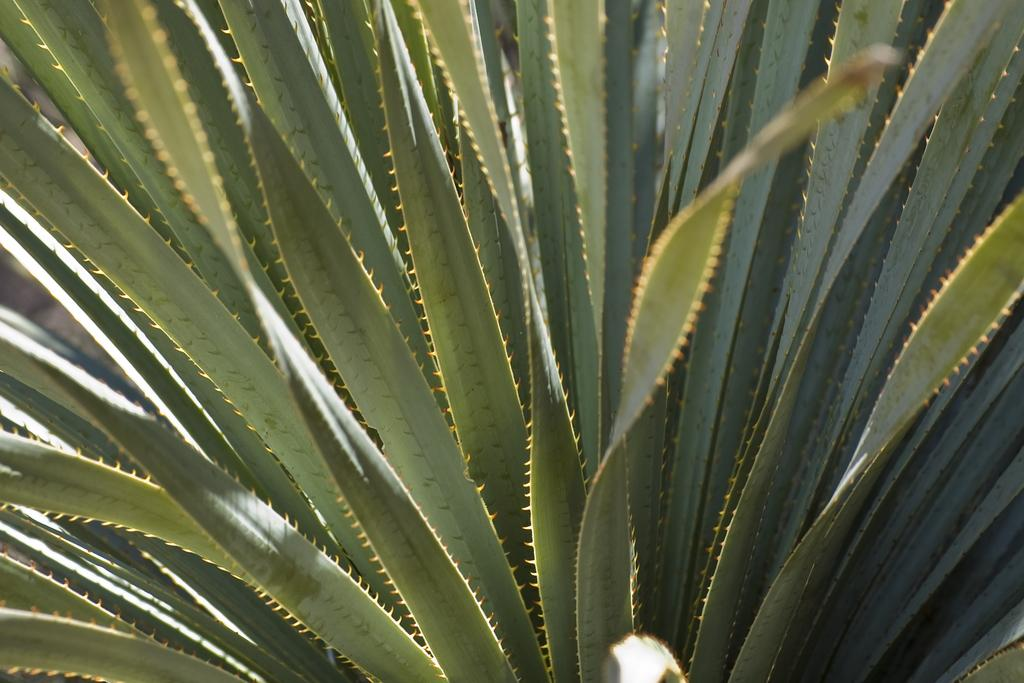What type of plant is visible in the image? There is a snake plant in the image. Can you describe the appearance of the snake plant? The snake plant has long, sword-shaped leaves that grow upright. What might be the purpose of having a snake plant in the image? The snake plant is known for its air-purifying properties and can help improve indoor air quality. How many bikes are parked next to the snake plant in the image? There are no bikes present in the image; it only features a snake plant. Is there any evidence of a spy in the image? There is no indication of a spy or any espionage-related activity in the image. 